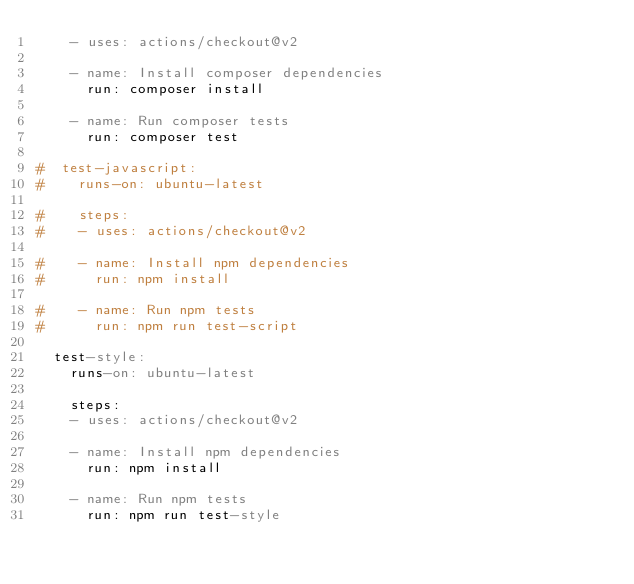Convert code to text. <code><loc_0><loc_0><loc_500><loc_500><_YAML_>    - uses: actions/checkout@v2

    - name: Install composer dependencies
      run: composer install

    - name: Run composer tests
      run: composer test

#  test-javascript:
#    runs-on: ubuntu-latest

#    steps:
#    - uses: actions/checkout@v2

#    - name: Install npm dependencies
#      run: npm install

#    - name: Run npm tests
#      run: npm run test-script

  test-style:
    runs-on: ubuntu-latest

    steps:
    - uses: actions/checkout@v2

    - name: Install npm dependencies
      run: npm install

    - name: Run npm tests
      run: npm run test-style
</code> 